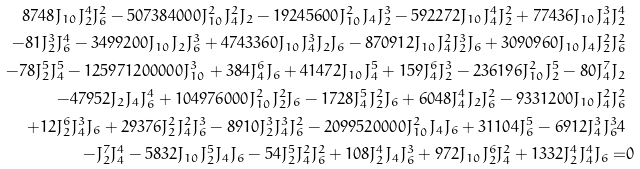<formula> <loc_0><loc_0><loc_500><loc_500>8 7 4 8 J _ { 1 0 } J _ { 2 } ^ { 4 } J _ { 6 } ^ { 2 } - 5 0 7 3 8 4 0 0 0 J _ { 1 0 } ^ { 2 } J _ { 4 } ^ { 2 } J _ { 2 } - 1 9 2 4 5 6 0 0 J _ { 1 0 } ^ { 2 } J _ { 4 } J _ { 2 } ^ { 3 } - 5 9 2 2 7 2 J _ { 1 0 } J _ { 4 } ^ { 4 } J _ { 2 } ^ { 2 } + 7 7 4 3 6 J _ { 1 0 } J _ { 4 } ^ { 3 } J _ { 2 } ^ { 4 } \\ - 8 1 J _ { 2 } ^ { 3 } J _ { 6 } ^ { 4 } - 3 4 9 9 2 0 0 J _ { 1 0 } J _ { 2 } J _ { 6 } ^ { 3 } + 4 7 4 3 3 6 0 J _ { 1 0 } J _ { 4 } ^ { 3 } J _ { 2 } J _ { 6 } - 8 7 0 9 1 2 J _ { 1 0 } J _ { 4 } ^ { 2 } J _ { 2 } ^ { 3 } J _ { 6 } + 3 0 9 0 9 6 0 J _ { 1 0 } J _ { 4 } J _ { 2 } ^ { 2 } J _ { 6 } ^ { 2 } \\ - 7 8 J _ { 2 } ^ { 5 } J _ { 4 } ^ { 5 } - 1 2 5 9 7 1 2 0 0 0 0 0 J _ { 1 0 } ^ { 3 } + 3 8 4 J _ { 4 } ^ { 6 } J _ { 6 } + 4 1 4 7 2 J _ { 1 0 } J _ { 4 } ^ { 5 } + 1 5 9 J _ { 4 } ^ { 6 } J _ { 2 } ^ { 3 } - 2 3 6 1 9 6 J _ { 1 0 } ^ { 2 } J _ { 2 } ^ { 5 } - 8 0 J _ { 4 } ^ { 7 } J _ { 2 } \\ - 4 7 9 5 2 J _ { 2 } J _ { 4 } J _ { 6 } ^ { 4 } + 1 0 4 9 7 6 0 0 0 J _ { 1 0 } ^ { 2 } J _ { 2 } ^ { 2 } J _ { 6 } - 1 7 2 8 J _ { 4 } ^ { 5 } J _ { 2 } ^ { 2 } J _ { 6 } + 6 0 4 8 J _ { 4 } ^ { 4 } J _ { 2 } J _ { 6 } ^ { 2 } - 9 3 3 1 2 0 0 J _ { 1 0 } J _ { 4 } ^ { 2 } J _ { 6 } ^ { 2 } \\ + 1 2 J _ { 2 } ^ { 6 } J _ { 4 } ^ { 3 } J _ { 6 } + 2 9 3 7 6 J _ { 2 } ^ { 2 } J _ { 4 } ^ { 2 } J _ { 6 } ^ { 3 } - 8 9 1 0 J _ { 2 } ^ { 3 } J _ { 4 } ^ { 3 } J _ { 6 } ^ { 2 } - 2 0 9 9 5 2 0 0 0 0 J _ { 1 0 } ^ { 2 } J _ { 4 } J _ { 6 } + 3 1 1 0 4 J _ { 6 } ^ { 5 } - 6 9 1 2 J _ { 4 } ^ { 3 } J _ { 6 } ^ { 3 } 4 \\ - J _ { 2 } ^ { 7 } J _ { 4 } ^ { 4 } - 5 8 3 2 J _ { 1 0 } J _ { 2 } ^ { 5 } J _ { 4 } J _ { 6 } - 5 4 J _ { 2 } ^ { 5 } J _ { 4 } ^ { 2 } J _ { 6 } ^ { 2 } + 1 0 8 J _ { 2 } ^ { 4 } J _ { 4 } J _ { 6 } ^ { 3 } + 9 7 2 J _ { 1 0 } J _ { 2 } ^ { 6 } J _ { 4 } ^ { 2 } + 1 3 3 2 J _ { 2 } ^ { 4 } J _ { 4 } ^ { 4 } J _ { 6 } = & 0</formula> 